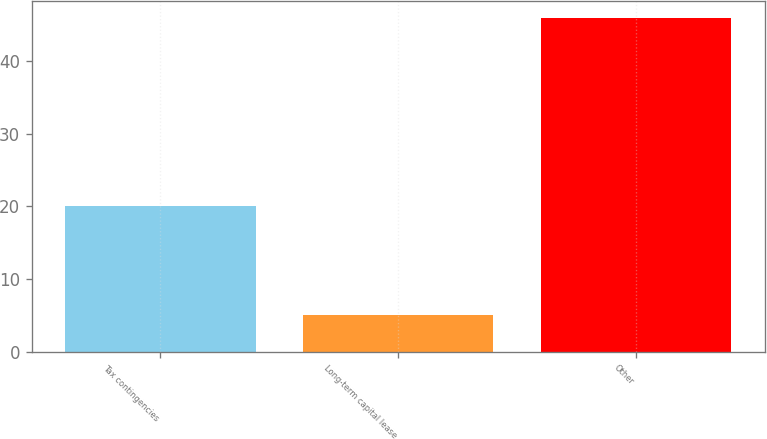<chart> <loc_0><loc_0><loc_500><loc_500><bar_chart><fcel>Tax contingencies<fcel>Long-term capital lease<fcel>Other<nl><fcel>20<fcel>5<fcel>46<nl></chart> 